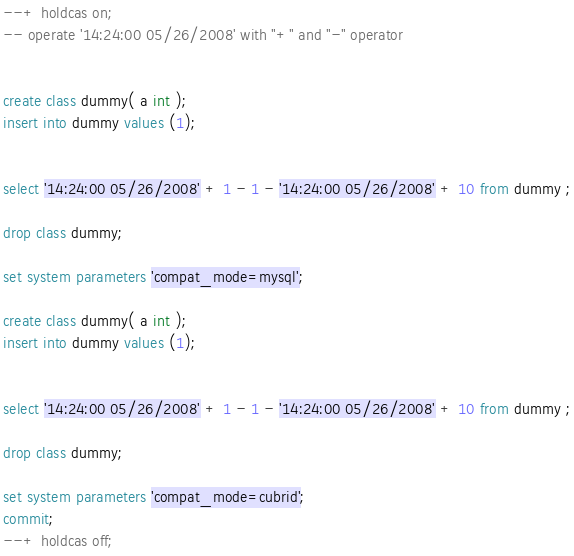<code> <loc_0><loc_0><loc_500><loc_500><_SQL_>--+ holdcas on;
-- operate '14:24:00 05/26/2008' with "+" and "-" operator


create class dummy( a int );
insert into dummy values (1);


select '14:24:00 05/26/2008' + 1 - 1 - '14:24:00 05/26/2008' + 10 from dummy ;

drop class dummy;

set system parameters 'compat_mode=mysql';

create class dummy( a int );
insert into dummy values (1);


select '14:24:00 05/26/2008' + 1 - 1 - '14:24:00 05/26/2008' + 10 from dummy ;

drop class dummy;

set system parameters 'compat_mode=cubrid';
commit;
--+ holdcas off;
</code> 